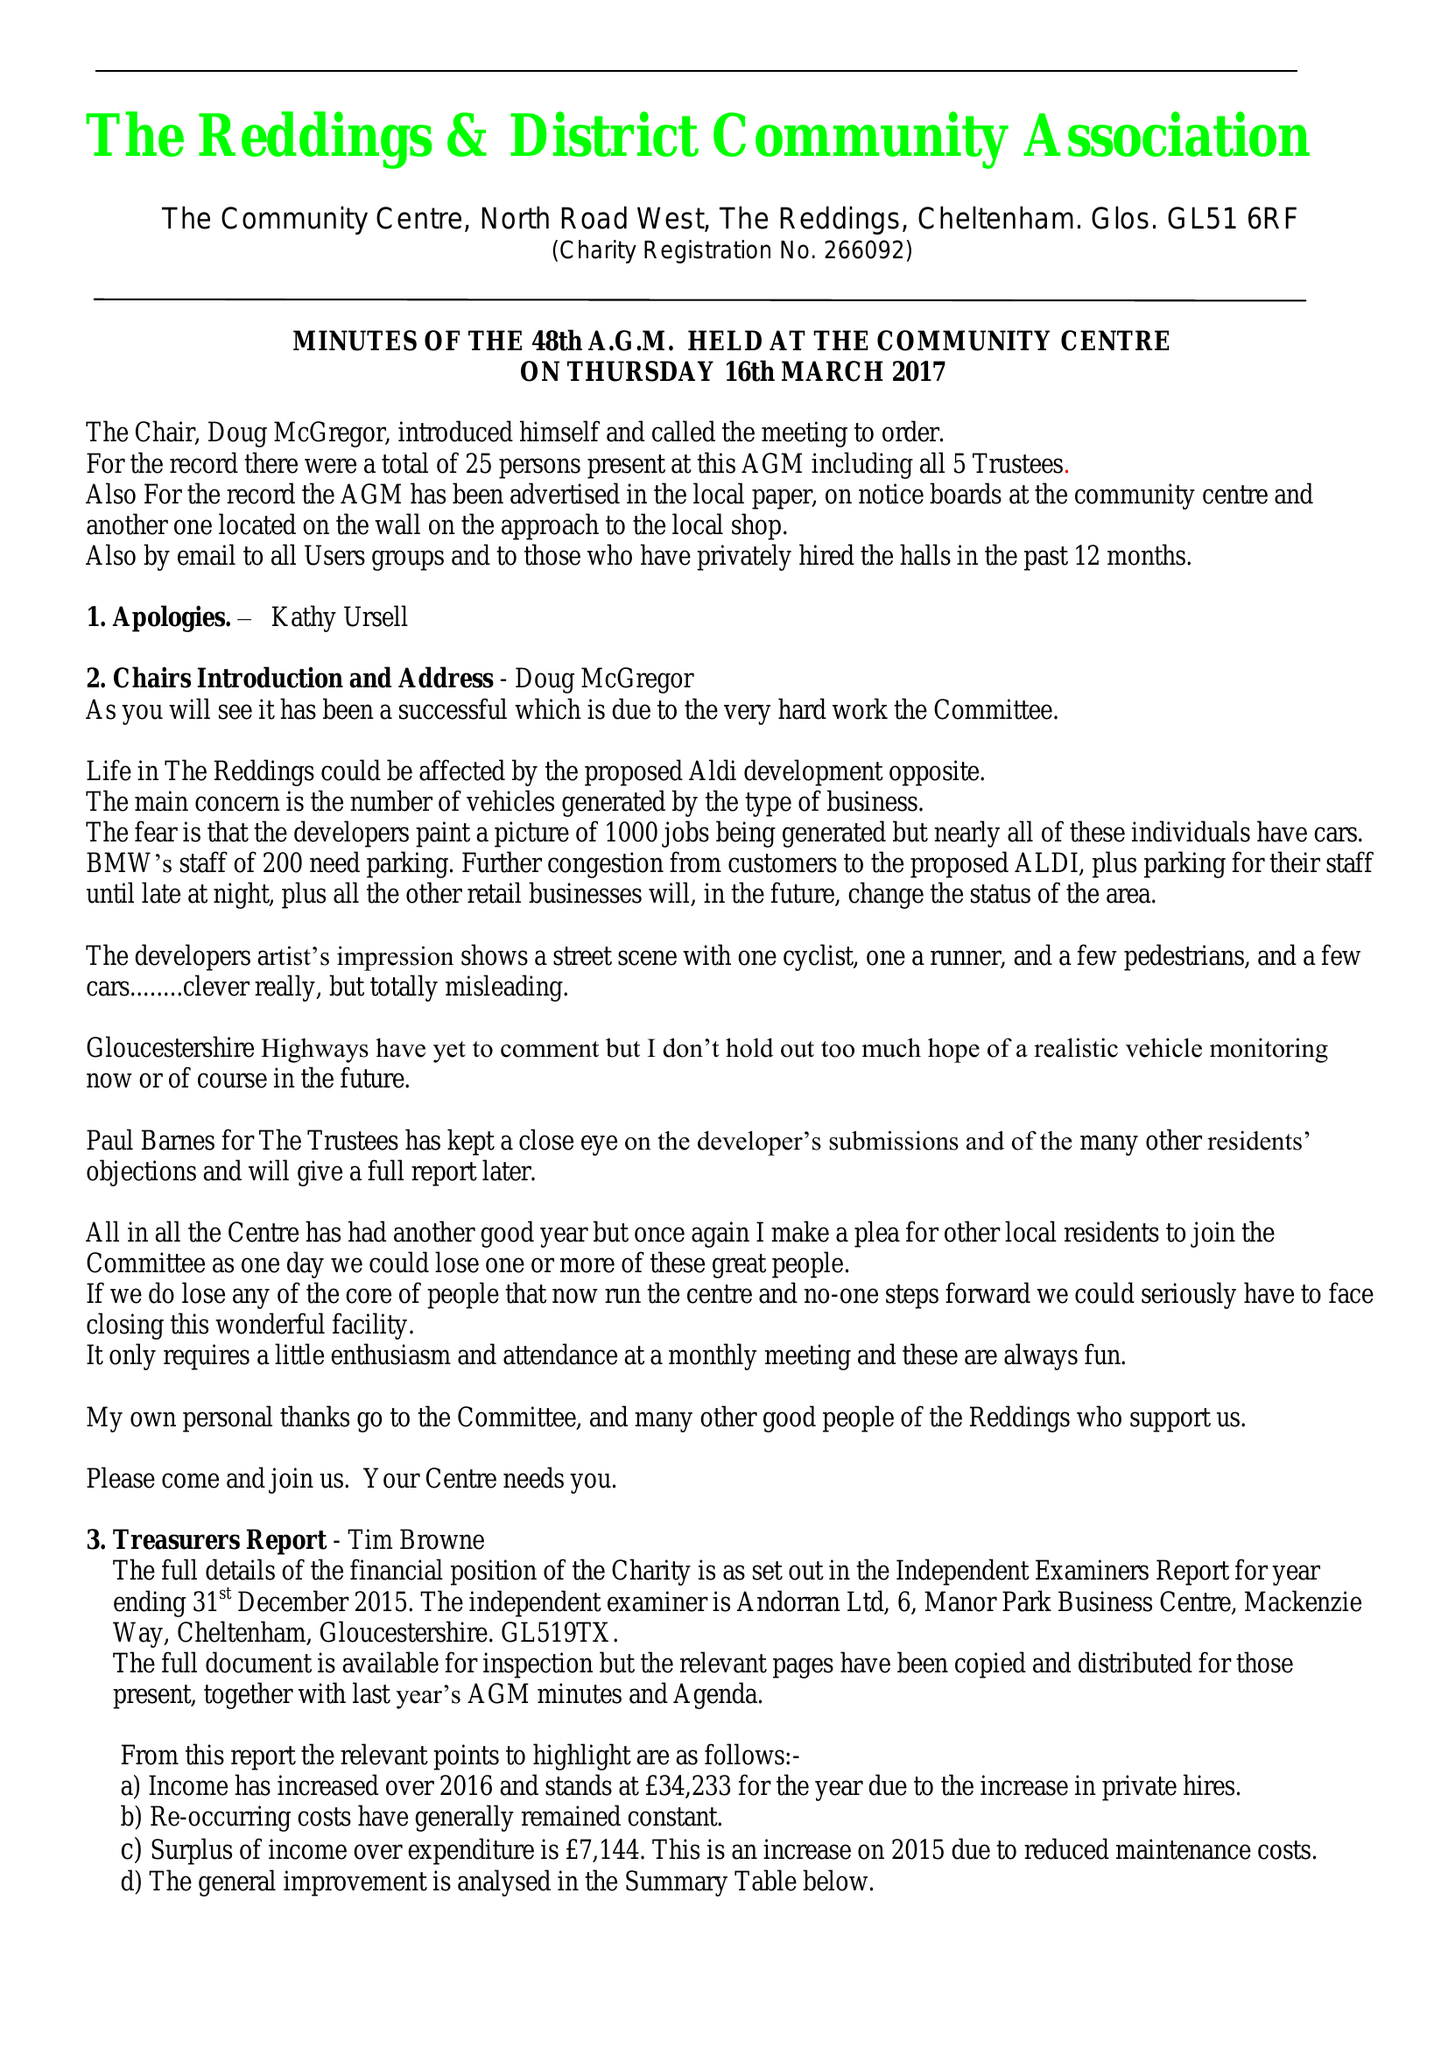What is the value for the address__postcode?
Answer the question using a single word or phrase. GL51 6RF 